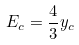<formula> <loc_0><loc_0><loc_500><loc_500>E _ { c } = \frac { 4 } { 3 } y _ { c }</formula> 